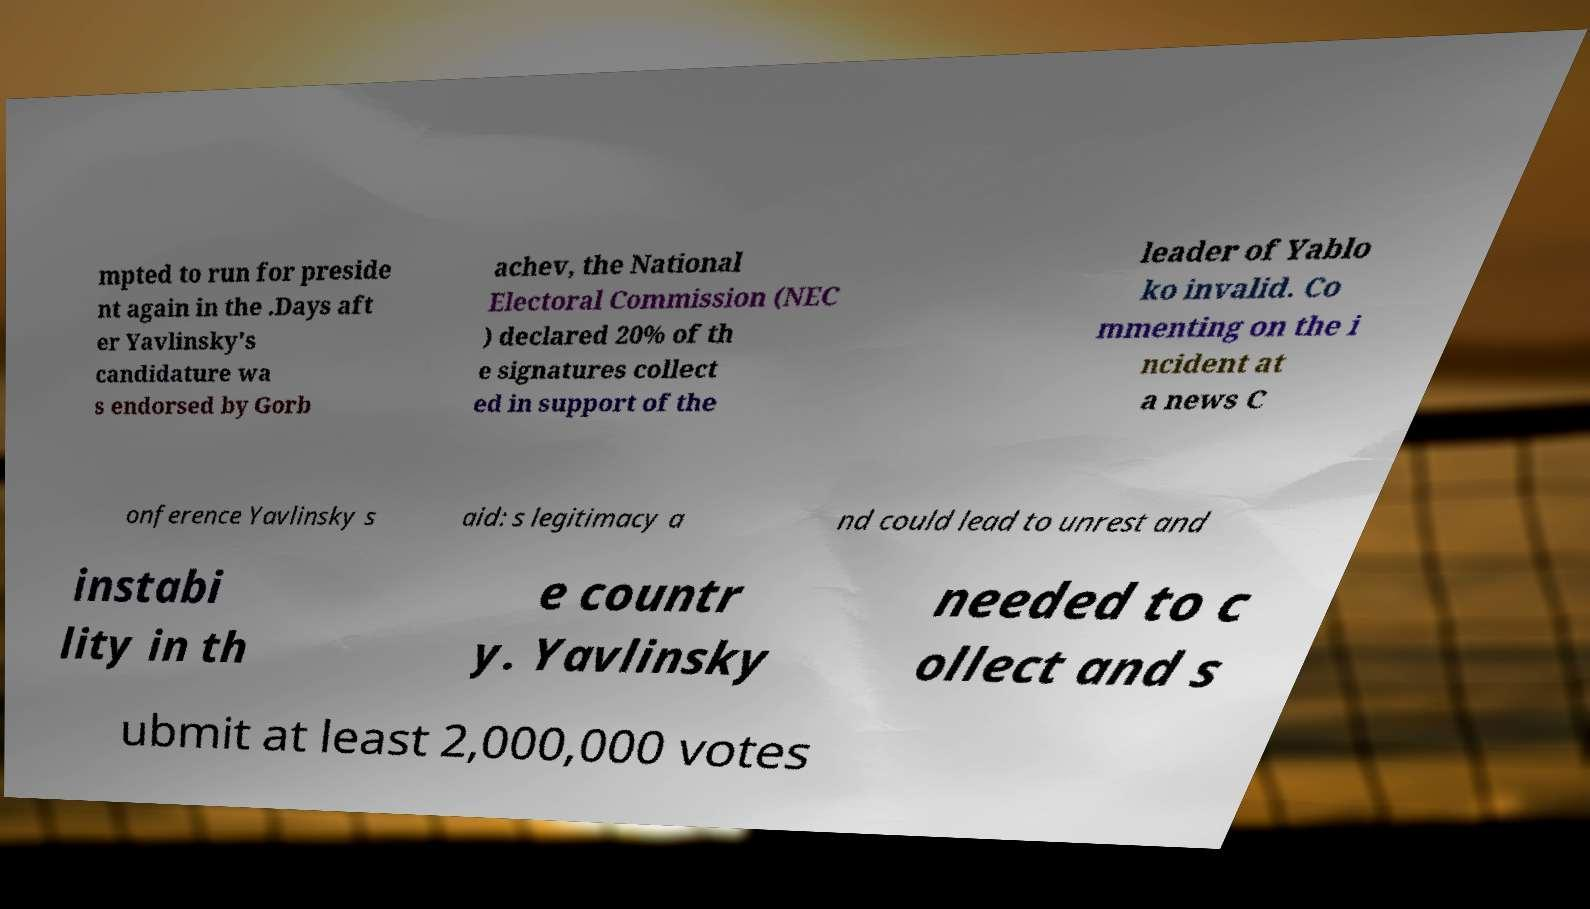What messages or text are displayed in this image? I need them in a readable, typed format. mpted to run for preside nt again in the .Days aft er Yavlinsky's candidature wa s endorsed by Gorb achev, the National Electoral Commission (NEC ) declared 20% of th e signatures collect ed in support of the leader of Yablo ko invalid. Co mmenting on the i ncident at a news C onference Yavlinsky s aid: s legitimacy a nd could lead to unrest and instabi lity in th e countr y. Yavlinsky needed to c ollect and s ubmit at least 2,000,000 votes 